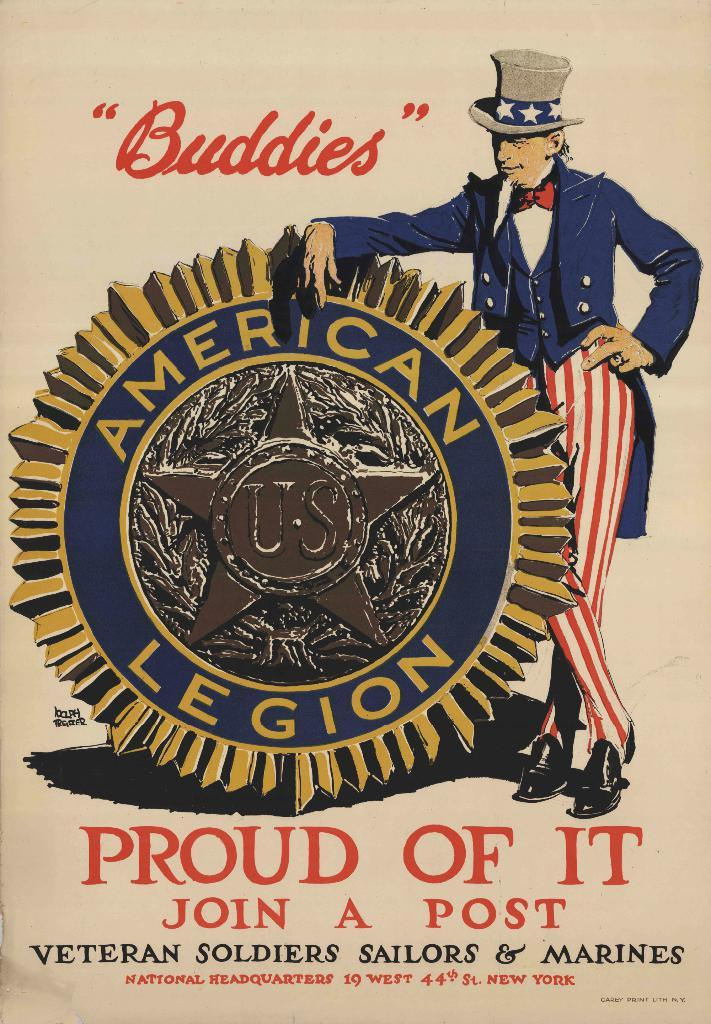<image>
Share a concise interpretation of the image provided. an American Legion "Buddies" poster saying Proud Of It. 